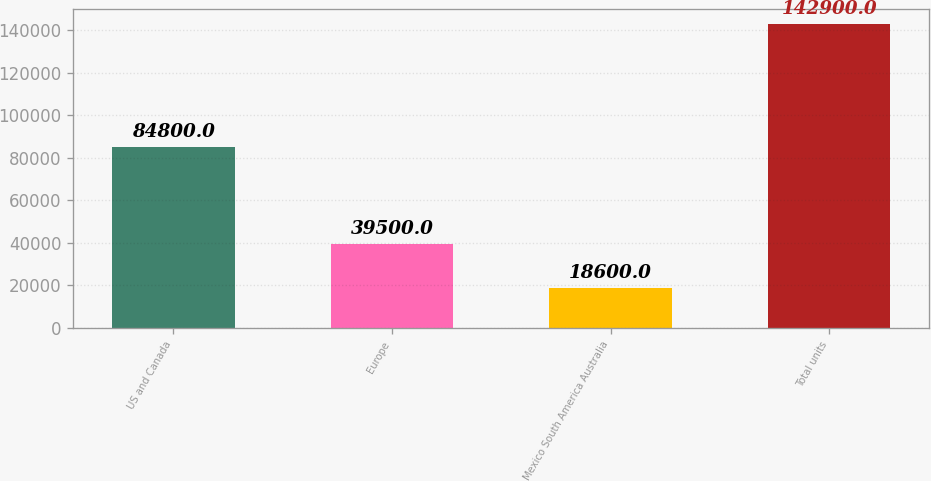Convert chart. <chart><loc_0><loc_0><loc_500><loc_500><bar_chart><fcel>US and Canada<fcel>Europe<fcel>Mexico South America Australia<fcel>Total units<nl><fcel>84800<fcel>39500<fcel>18600<fcel>142900<nl></chart> 